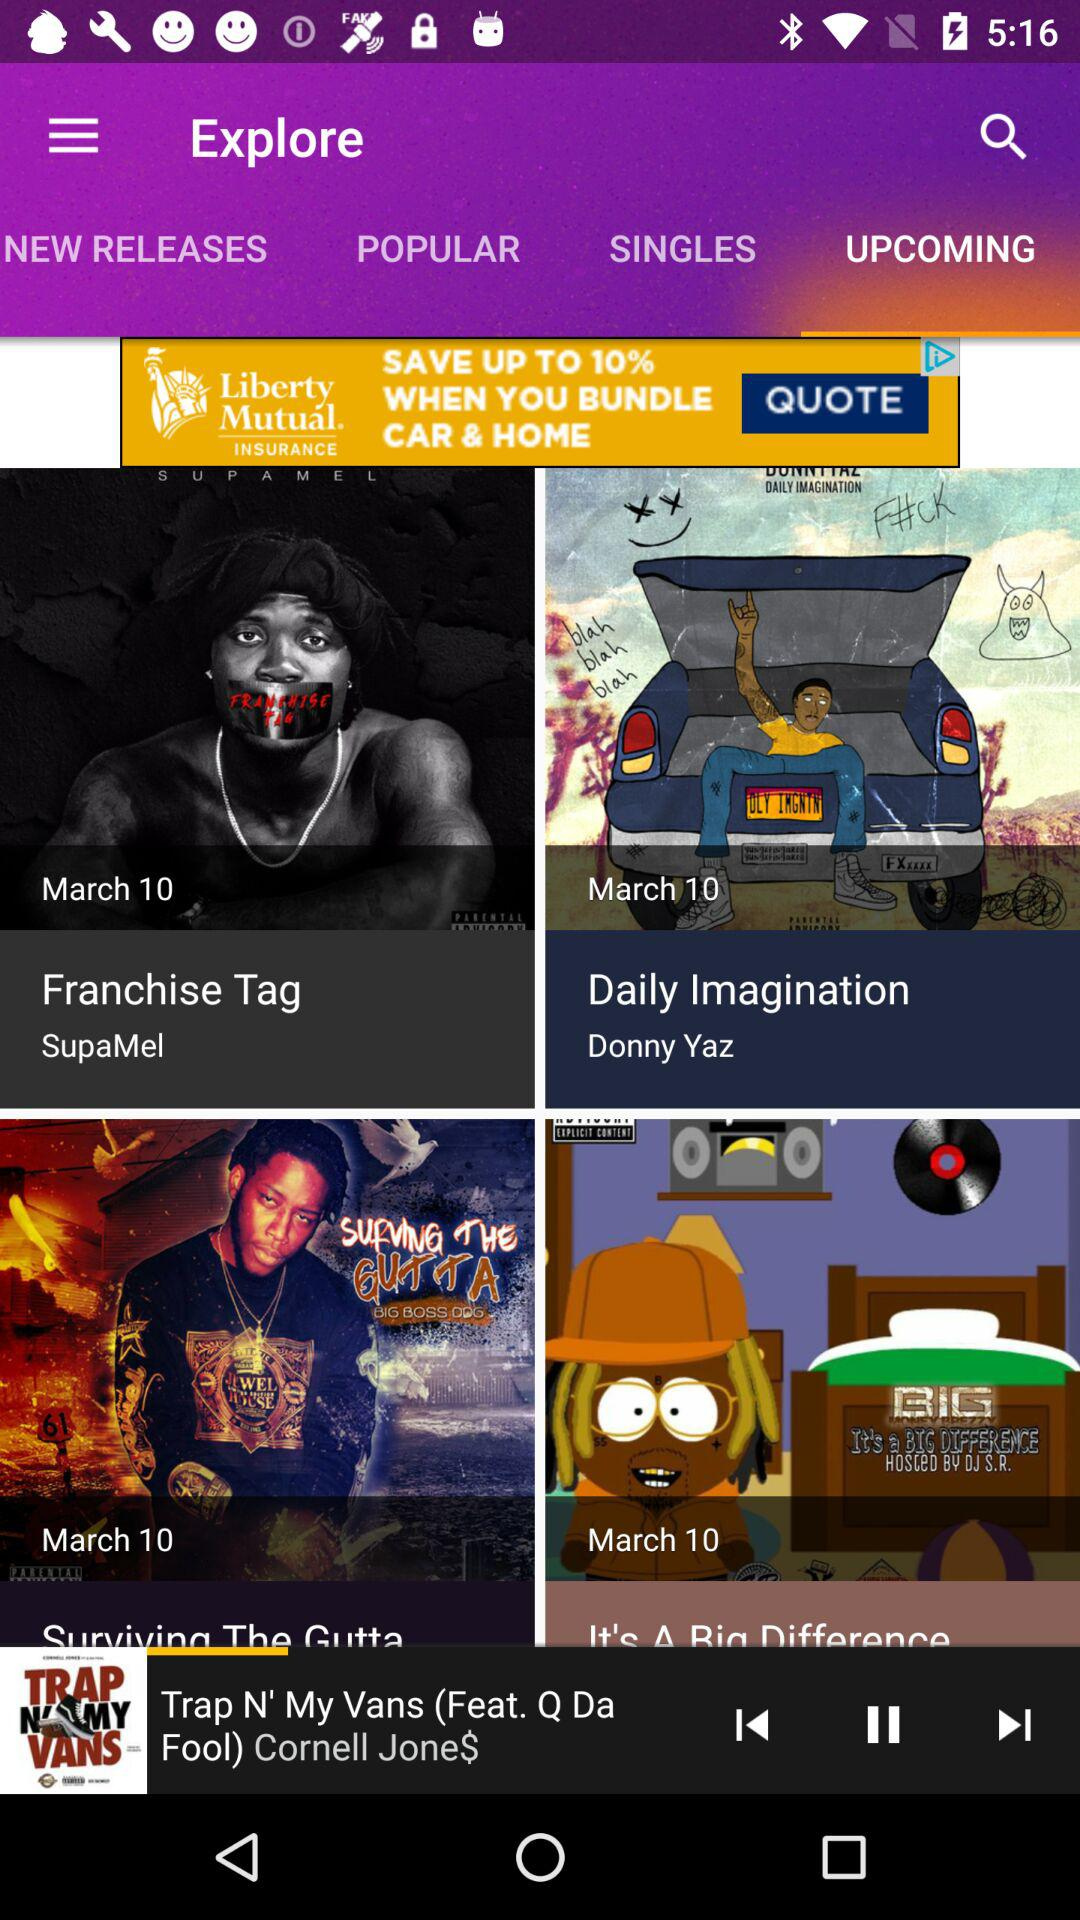Which song is currently playing? The song playing is "Trap N' My Vans". 